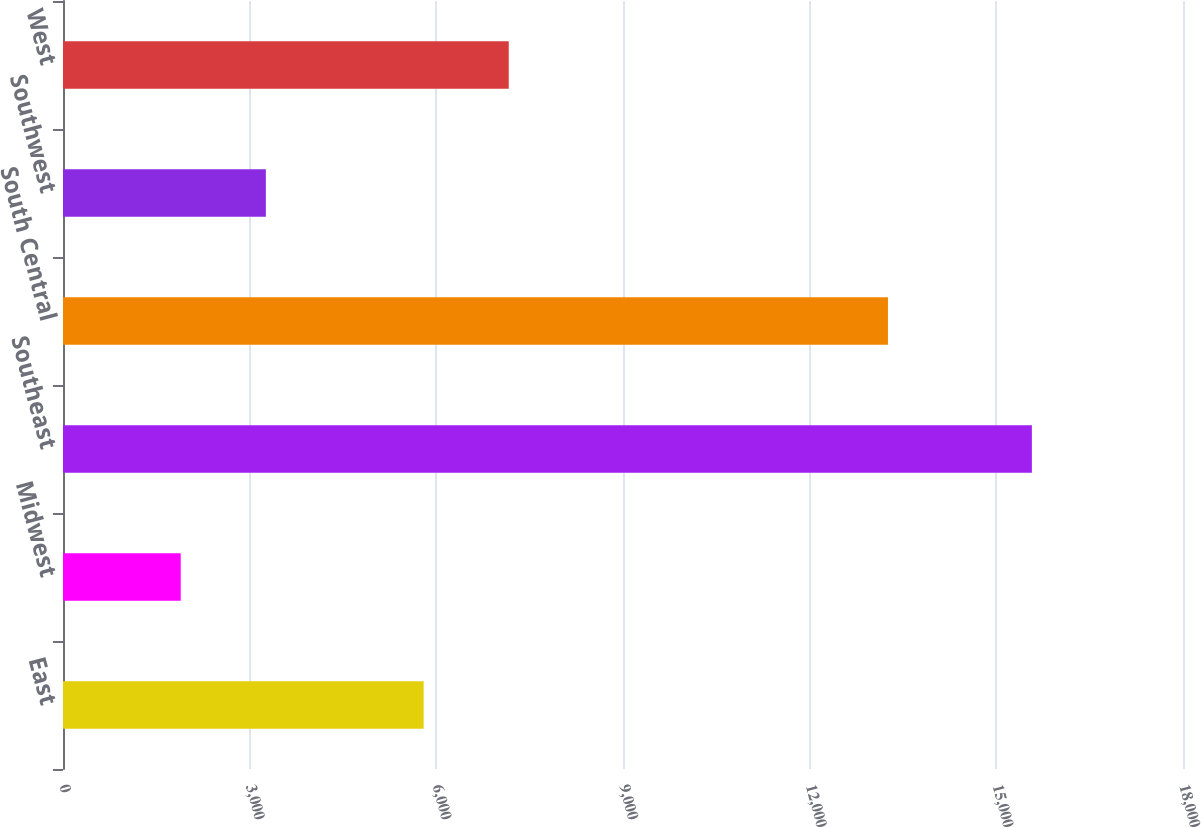Convert chart to OTSL. <chart><loc_0><loc_0><loc_500><loc_500><bar_chart><fcel>East<fcel>Midwest<fcel>Southeast<fcel>South Central<fcel>Southwest<fcel>West<nl><fcel>5796<fcel>1892<fcel>15571<fcel>13258<fcel>3259.9<fcel>7163.9<nl></chart> 